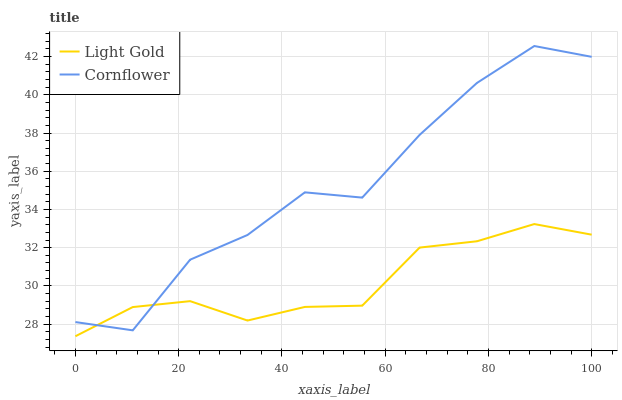Does Light Gold have the minimum area under the curve?
Answer yes or no. Yes. Does Cornflower have the maximum area under the curve?
Answer yes or no. Yes. Does Light Gold have the maximum area under the curve?
Answer yes or no. No. Is Light Gold the smoothest?
Answer yes or no. Yes. Is Cornflower the roughest?
Answer yes or no. Yes. Is Light Gold the roughest?
Answer yes or no. No. Does Light Gold have the lowest value?
Answer yes or no. Yes. Does Cornflower have the highest value?
Answer yes or no. Yes. Does Light Gold have the highest value?
Answer yes or no. No. Does Light Gold intersect Cornflower?
Answer yes or no. Yes. Is Light Gold less than Cornflower?
Answer yes or no. No. Is Light Gold greater than Cornflower?
Answer yes or no. No. 